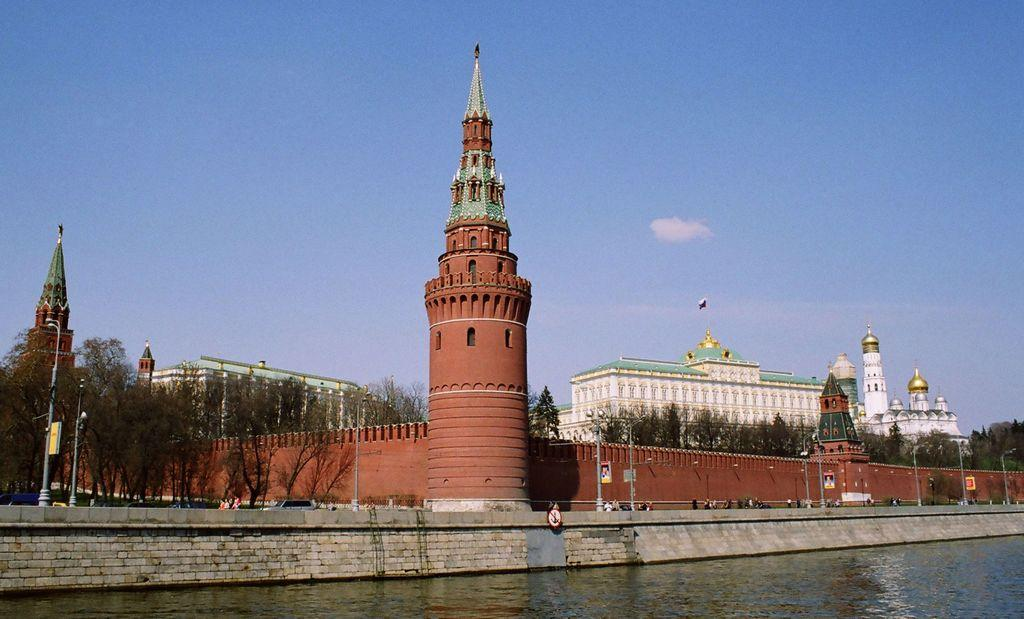What type of structures can be seen in the image? There are buildings in the image. What natural elements are present in the image? There are trees in the image. What man-made objects can be seen in the image? There are poles and boards present in the image. What symbolic object is visible in the image? There is a flag in the image. What can be seen at the bottom of the image? There is water visible at the bottom of the image. What is visible at the top of the image? There is sky visible at the top of the image. Reasoning: Let's think step by step by step in order to produce the conversation. We start by identifying the main subjects and objects in the image based on the provided facts. We then formulate questions that focus on the location and characteristics of these subjects and objects, ensuring that each question can be answered definitively with the information given. We avoid yes/no questions and ensure that the language is simple and clear. Absurd Question/Answer: How many bears are climbing the buildings in the image? There are no bears present in the image; it features buildings, trees, poles, boards, a flag, water, and sky. What is the highest point in the image? The highest point in the image is the sky visible at the top, but there is no specific reference to a "top" in the image. What type of earthquake is causing the buildings to sway in the image? There is no indication of an earthquake or swaying buildings in the image; it features buildings, trees, poles, boards, a flag, water, and sky. 